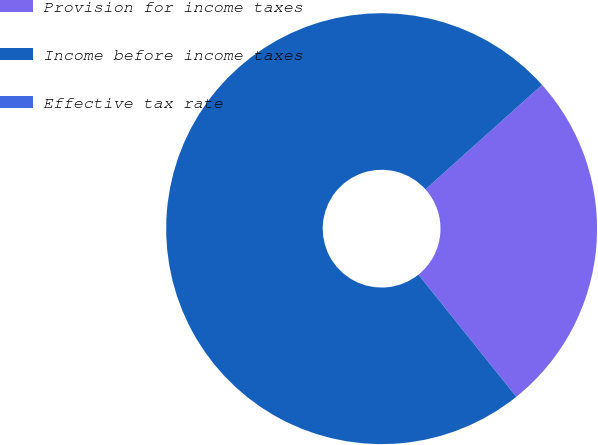Convert chart to OTSL. <chart><loc_0><loc_0><loc_500><loc_500><pie_chart><fcel>Provision for income taxes<fcel>Income before income taxes<fcel>Effective tax rate<nl><fcel>25.88%<fcel>74.11%<fcel>0.0%<nl></chart> 